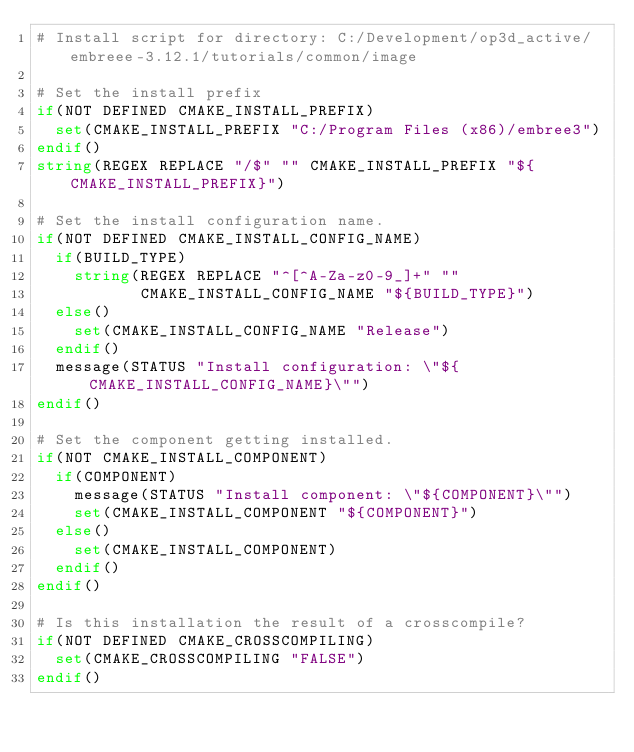<code> <loc_0><loc_0><loc_500><loc_500><_CMake_># Install script for directory: C:/Development/op3d_active/embreee-3.12.1/tutorials/common/image

# Set the install prefix
if(NOT DEFINED CMAKE_INSTALL_PREFIX)
  set(CMAKE_INSTALL_PREFIX "C:/Program Files (x86)/embree3")
endif()
string(REGEX REPLACE "/$" "" CMAKE_INSTALL_PREFIX "${CMAKE_INSTALL_PREFIX}")

# Set the install configuration name.
if(NOT DEFINED CMAKE_INSTALL_CONFIG_NAME)
  if(BUILD_TYPE)
    string(REGEX REPLACE "^[^A-Za-z0-9_]+" ""
           CMAKE_INSTALL_CONFIG_NAME "${BUILD_TYPE}")
  else()
    set(CMAKE_INSTALL_CONFIG_NAME "Release")
  endif()
  message(STATUS "Install configuration: \"${CMAKE_INSTALL_CONFIG_NAME}\"")
endif()

# Set the component getting installed.
if(NOT CMAKE_INSTALL_COMPONENT)
  if(COMPONENT)
    message(STATUS "Install component: \"${COMPONENT}\"")
    set(CMAKE_INSTALL_COMPONENT "${COMPONENT}")
  else()
    set(CMAKE_INSTALL_COMPONENT)
  endif()
endif()

# Is this installation the result of a crosscompile?
if(NOT DEFINED CMAKE_CROSSCOMPILING)
  set(CMAKE_CROSSCOMPILING "FALSE")
endif()

</code> 